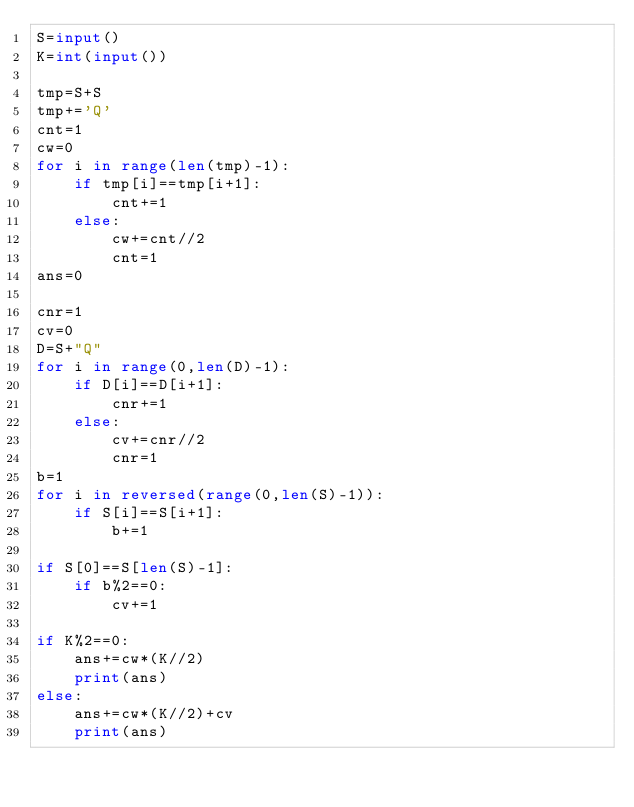<code> <loc_0><loc_0><loc_500><loc_500><_Python_>S=input()
K=int(input())

tmp=S+S
tmp+='Q'
cnt=1
cw=0
for i in range(len(tmp)-1):
    if tmp[i]==tmp[i+1]:
        cnt+=1
    else:
        cw+=cnt//2
        cnt=1
ans=0

cnr=1
cv=0
D=S+"Q"
for i in range(0,len(D)-1):
    if D[i]==D[i+1]:
        cnr+=1
    else:
        cv+=cnr//2
        cnr=1
b=1
for i in reversed(range(0,len(S)-1)):
    if S[i]==S[i+1]:
        b+=1

if S[0]==S[len(S)-1]:
    if b%2==0:
        cv+=1

if K%2==0:
    ans+=cw*(K//2)
    print(ans)
else:
    ans+=cw*(K//2)+cv
    print(ans)</code> 